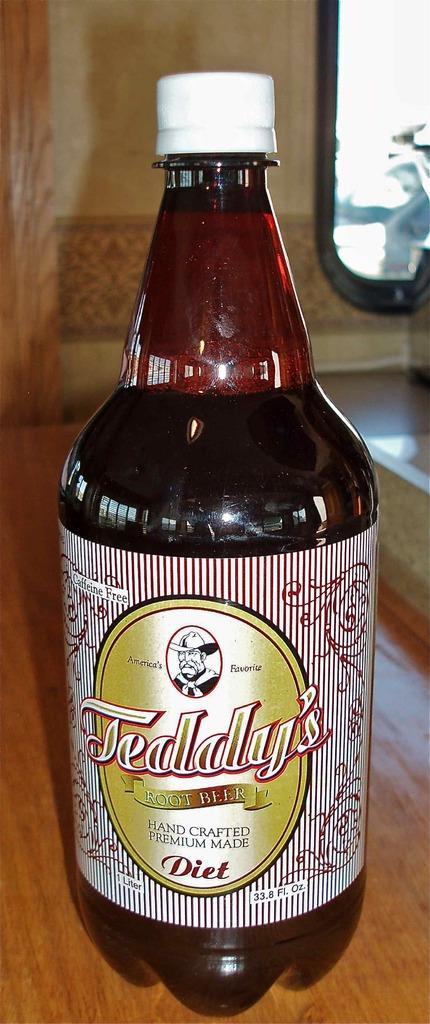Describe this image in one or two sentences. There is a bottle with a label is placed on a table. In the background there is a wall. 